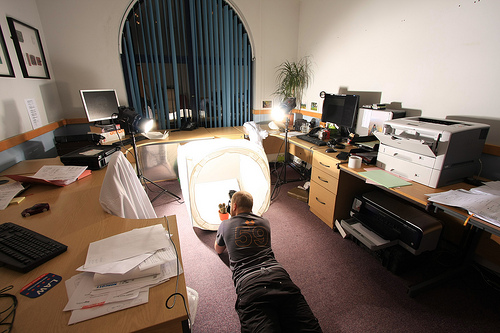<image>
Is the man under the desk? No. The man is not positioned under the desk. The vertical relationship between these objects is different. Is the keyboard behind the desktop? No. The keyboard is not behind the desktop. From this viewpoint, the keyboard appears to be positioned elsewhere in the scene. 